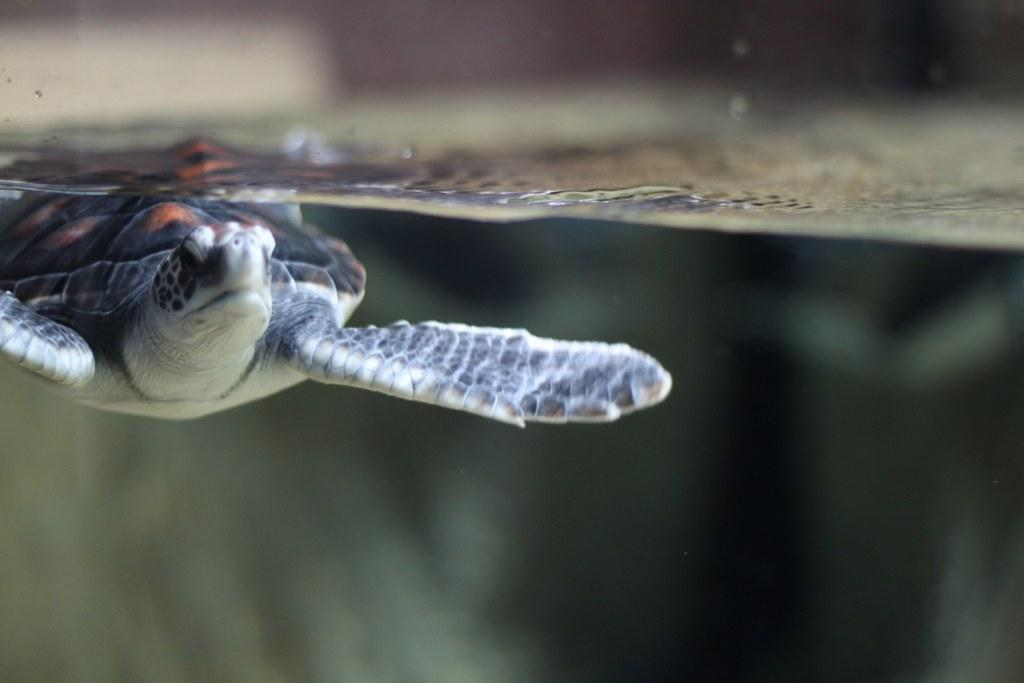What type of animal is in the image? There is a tortoise in the image. How is the tortoise positioned in the image? The tortoise is in an inverted direction. What thoughts does the doll have about the tortoise in the image? There is no doll present in the image, so it is not possible to determine any thoughts the doll might have about the tortoise. 